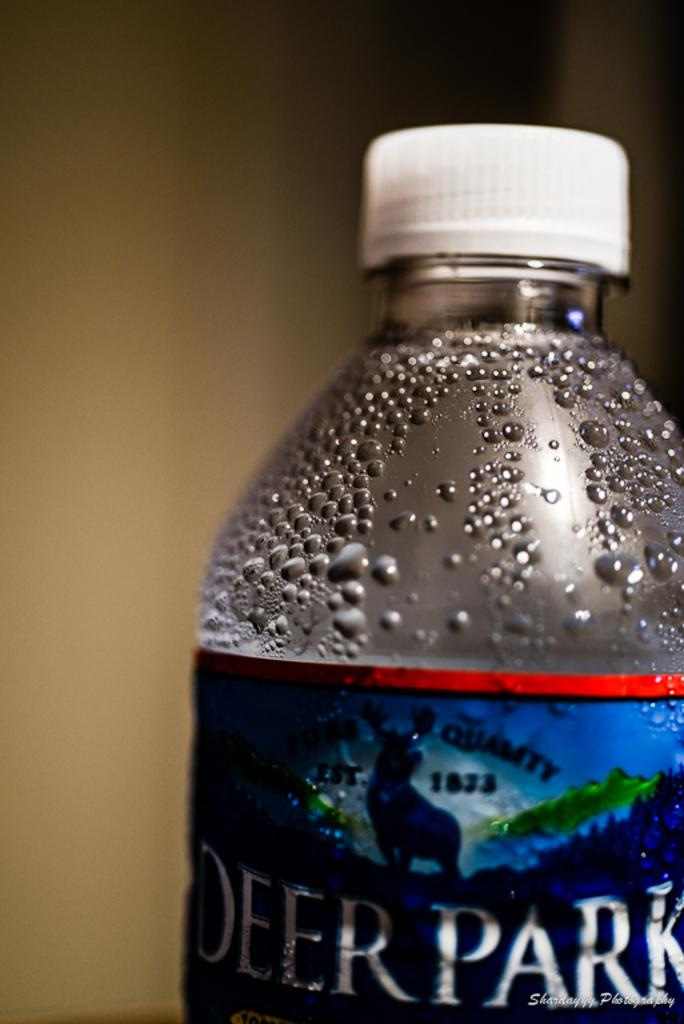What object can be seen in the image? There is a bottle in the image. What type of pain is being experienced by the person in the image? There is no person present in the image, and therefore no pain can be observed or experienced. 